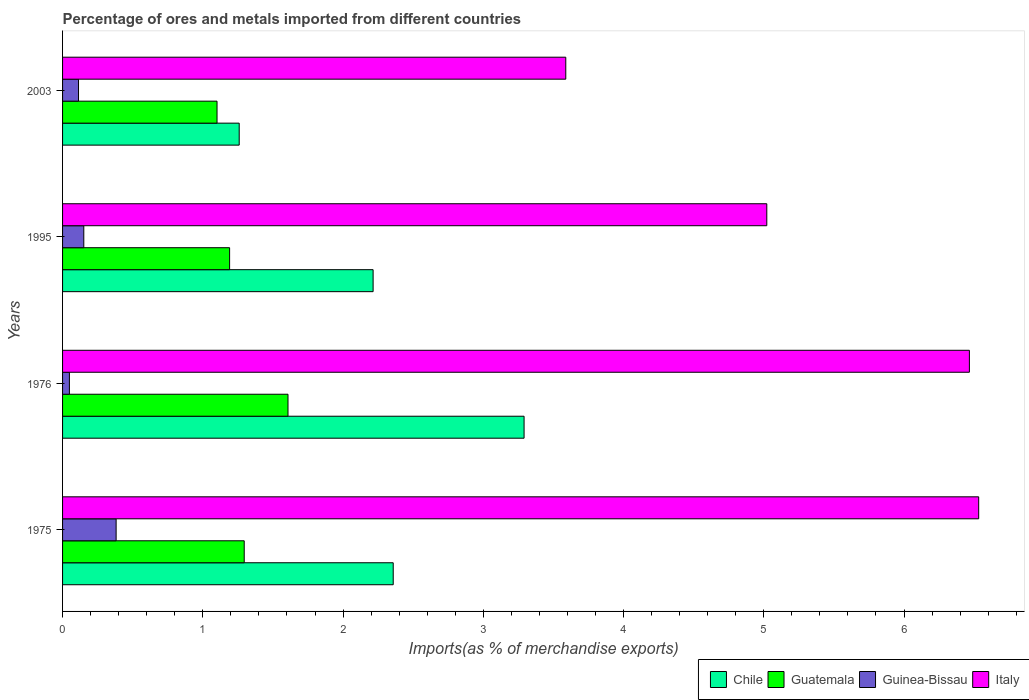How many different coloured bars are there?
Provide a succinct answer. 4. How many groups of bars are there?
Your answer should be compact. 4. Are the number of bars per tick equal to the number of legend labels?
Offer a terse response. Yes. Are the number of bars on each tick of the Y-axis equal?
Provide a succinct answer. Yes. How many bars are there on the 2nd tick from the bottom?
Ensure brevity in your answer.  4. What is the percentage of imports to different countries in Italy in 1976?
Give a very brief answer. 6.47. Across all years, what is the maximum percentage of imports to different countries in Chile?
Offer a very short reply. 3.29. Across all years, what is the minimum percentage of imports to different countries in Italy?
Your response must be concise. 3.59. In which year was the percentage of imports to different countries in Italy maximum?
Your answer should be compact. 1975. What is the total percentage of imports to different countries in Guinea-Bissau in the graph?
Your response must be concise. 0.7. What is the difference between the percentage of imports to different countries in Guatemala in 1976 and that in 2003?
Offer a terse response. 0.51. What is the difference between the percentage of imports to different countries in Italy in 1995 and the percentage of imports to different countries in Guinea-Bissau in 2003?
Ensure brevity in your answer.  4.91. What is the average percentage of imports to different countries in Italy per year?
Your answer should be compact. 5.4. In the year 2003, what is the difference between the percentage of imports to different countries in Guinea-Bissau and percentage of imports to different countries in Chile?
Offer a terse response. -1.15. In how many years, is the percentage of imports to different countries in Guatemala greater than 6.4 %?
Ensure brevity in your answer.  0. What is the ratio of the percentage of imports to different countries in Chile in 1975 to that in 1995?
Your answer should be very brief. 1.06. Is the difference between the percentage of imports to different countries in Guinea-Bissau in 1975 and 1995 greater than the difference between the percentage of imports to different countries in Chile in 1975 and 1995?
Ensure brevity in your answer.  Yes. What is the difference between the highest and the second highest percentage of imports to different countries in Guatemala?
Offer a terse response. 0.31. What is the difference between the highest and the lowest percentage of imports to different countries in Guatemala?
Make the answer very short. 0.51. Is it the case that in every year, the sum of the percentage of imports to different countries in Guatemala and percentage of imports to different countries in Guinea-Bissau is greater than the sum of percentage of imports to different countries in Italy and percentage of imports to different countries in Chile?
Provide a short and direct response. No. Is it the case that in every year, the sum of the percentage of imports to different countries in Guinea-Bissau and percentage of imports to different countries in Chile is greater than the percentage of imports to different countries in Italy?
Provide a succinct answer. No. How many bars are there?
Your response must be concise. 16. Does the graph contain any zero values?
Offer a terse response. No. Where does the legend appear in the graph?
Your response must be concise. Bottom right. How are the legend labels stacked?
Give a very brief answer. Horizontal. What is the title of the graph?
Your answer should be compact. Percentage of ores and metals imported from different countries. Does "Iceland" appear as one of the legend labels in the graph?
Make the answer very short. No. What is the label or title of the X-axis?
Give a very brief answer. Imports(as % of merchandise exports). What is the label or title of the Y-axis?
Provide a succinct answer. Years. What is the Imports(as % of merchandise exports) of Chile in 1975?
Your answer should be very brief. 2.36. What is the Imports(as % of merchandise exports) in Guatemala in 1975?
Keep it short and to the point. 1.3. What is the Imports(as % of merchandise exports) of Guinea-Bissau in 1975?
Your answer should be very brief. 0.38. What is the Imports(as % of merchandise exports) in Italy in 1975?
Give a very brief answer. 6.53. What is the Imports(as % of merchandise exports) of Chile in 1976?
Your response must be concise. 3.29. What is the Imports(as % of merchandise exports) in Guatemala in 1976?
Your response must be concise. 1.61. What is the Imports(as % of merchandise exports) in Guinea-Bissau in 1976?
Give a very brief answer. 0.05. What is the Imports(as % of merchandise exports) of Italy in 1976?
Ensure brevity in your answer.  6.47. What is the Imports(as % of merchandise exports) in Chile in 1995?
Offer a terse response. 2.21. What is the Imports(as % of merchandise exports) of Guatemala in 1995?
Your response must be concise. 1.19. What is the Imports(as % of merchandise exports) of Guinea-Bissau in 1995?
Give a very brief answer. 0.15. What is the Imports(as % of merchandise exports) in Italy in 1995?
Offer a terse response. 5.02. What is the Imports(as % of merchandise exports) of Chile in 2003?
Ensure brevity in your answer.  1.26. What is the Imports(as % of merchandise exports) of Guatemala in 2003?
Your answer should be compact. 1.1. What is the Imports(as % of merchandise exports) of Guinea-Bissau in 2003?
Provide a short and direct response. 0.11. What is the Imports(as % of merchandise exports) in Italy in 2003?
Provide a succinct answer. 3.59. Across all years, what is the maximum Imports(as % of merchandise exports) of Chile?
Make the answer very short. 3.29. Across all years, what is the maximum Imports(as % of merchandise exports) of Guatemala?
Your answer should be compact. 1.61. Across all years, what is the maximum Imports(as % of merchandise exports) of Guinea-Bissau?
Keep it short and to the point. 0.38. Across all years, what is the maximum Imports(as % of merchandise exports) in Italy?
Your answer should be compact. 6.53. Across all years, what is the minimum Imports(as % of merchandise exports) in Chile?
Ensure brevity in your answer.  1.26. Across all years, what is the minimum Imports(as % of merchandise exports) in Guatemala?
Your response must be concise. 1.1. Across all years, what is the minimum Imports(as % of merchandise exports) of Guinea-Bissau?
Your response must be concise. 0.05. Across all years, what is the minimum Imports(as % of merchandise exports) in Italy?
Make the answer very short. 3.59. What is the total Imports(as % of merchandise exports) of Chile in the graph?
Offer a terse response. 9.12. What is the total Imports(as % of merchandise exports) of Guatemala in the graph?
Your answer should be compact. 5.2. What is the total Imports(as % of merchandise exports) of Guinea-Bissau in the graph?
Your answer should be compact. 0.7. What is the total Imports(as % of merchandise exports) of Italy in the graph?
Provide a short and direct response. 21.61. What is the difference between the Imports(as % of merchandise exports) in Chile in 1975 and that in 1976?
Keep it short and to the point. -0.93. What is the difference between the Imports(as % of merchandise exports) of Guatemala in 1975 and that in 1976?
Your response must be concise. -0.31. What is the difference between the Imports(as % of merchandise exports) of Guinea-Bissau in 1975 and that in 1976?
Provide a succinct answer. 0.33. What is the difference between the Imports(as % of merchandise exports) in Italy in 1975 and that in 1976?
Offer a very short reply. 0.07. What is the difference between the Imports(as % of merchandise exports) of Chile in 1975 and that in 1995?
Provide a succinct answer. 0.14. What is the difference between the Imports(as % of merchandise exports) in Guatemala in 1975 and that in 1995?
Make the answer very short. 0.1. What is the difference between the Imports(as % of merchandise exports) of Guinea-Bissau in 1975 and that in 1995?
Offer a very short reply. 0.23. What is the difference between the Imports(as % of merchandise exports) in Italy in 1975 and that in 1995?
Offer a terse response. 1.51. What is the difference between the Imports(as % of merchandise exports) in Chile in 1975 and that in 2003?
Offer a very short reply. 1.1. What is the difference between the Imports(as % of merchandise exports) in Guatemala in 1975 and that in 2003?
Your answer should be compact. 0.19. What is the difference between the Imports(as % of merchandise exports) in Guinea-Bissau in 1975 and that in 2003?
Your answer should be compact. 0.27. What is the difference between the Imports(as % of merchandise exports) in Italy in 1975 and that in 2003?
Provide a succinct answer. 2.94. What is the difference between the Imports(as % of merchandise exports) of Chile in 1976 and that in 1995?
Offer a terse response. 1.08. What is the difference between the Imports(as % of merchandise exports) of Guatemala in 1976 and that in 1995?
Your response must be concise. 0.42. What is the difference between the Imports(as % of merchandise exports) in Guinea-Bissau in 1976 and that in 1995?
Your answer should be very brief. -0.1. What is the difference between the Imports(as % of merchandise exports) of Italy in 1976 and that in 1995?
Your response must be concise. 1.44. What is the difference between the Imports(as % of merchandise exports) of Chile in 1976 and that in 2003?
Your answer should be compact. 2.03. What is the difference between the Imports(as % of merchandise exports) in Guatemala in 1976 and that in 2003?
Your answer should be compact. 0.51. What is the difference between the Imports(as % of merchandise exports) in Guinea-Bissau in 1976 and that in 2003?
Offer a terse response. -0.07. What is the difference between the Imports(as % of merchandise exports) in Italy in 1976 and that in 2003?
Provide a succinct answer. 2.88. What is the difference between the Imports(as % of merchandise exports) in Chile in 1995 and that in 2003?
Ensure brevity in your answer.  0.95. What is the difference between the Imports(as % of merchandise exports) in Guatemala in 1995 and that in 2003?
Your answer should be very brief. 0.09. What is the difference between the Imports(as % of merchandise exports) in Guinea-Bissau in 1995 and that in 2003?
Keep it short and to the point. 0.04. What is the difference between the Imports(as % of merchandise exports) of Italy in 1995 and that in 2003?
Ensure brevity in your answer.  1.43. What is the difference between the Imports(as % of merchandise exports) in Chile in 1975 and the Imports(as % of merchandise exports) in Guatemala in 1976?
Offer a terse response. 0.75. What is the difference between the Imports(as % of merchandise exports) in Chile in 1975 and the Imports(as % of merchandise exports) in Guinea-Bissau in 1976?
Give a very brief answer. 2.31. What is the difference between the Imports(as % of merchandise exports) of Chile in 1975 and the Imports(as % of merchandise exports) of Italy in 1976?
Provide a short and direct response. -4.11. What is the difference between the Imports(as % of merchandise exports) of Guatemala in 1975 and the Imports(as % of merchandise exports) of Guinea-Bissau in 1976?
Offer a terse response. 1.25. What is the difference between the Imports(as % of merchandise exports) of Guatemala in 1975 and the Imports(as % of merchandise exports) of Italy in 1976?
Give a very brief answer. -5.17. What is the difference between the Imports(as % of merchandise exports) in Guinea-Bissau in 1975 and the Imports(as % of merchandise exports) in Italy in 1976?
Offer a terse response. -6.08. What is the difference between the Imports(as % of merchandise exports) in Chile in 1975 and the Imports(as % of merchandise exports) in Guatemala in 1995?
Your answer should be compact. 1.17. What is the difference between the Imports(as % of merchandise exports) of Chile in 1975 and the Imports(as % of merchandise exports) of Guinea-Bissau in 1995?
Provide a succinct answer. 2.21. What is the difference between the Imports(as % of merchandise exports) of Chile in 1975 and the Imports(as % of merchandise exports) of Italy in 1995?
Offer a very short reply. -2.66. What is the difference between the Imports(as % of merchandise exports) in Guatemala in 1975 and the Imports(as % of merchandise exports) in Guinea-Bissau in 1995?
Offer a very short reply. 1.14. What is the difference between the Imports(as % of merchandise exports) of Guatemala in 1975 and the Imports(as % of merchandise exports) of Italy in 1995?
Provide a short and direct response. -3.73. What is the difference between the Imports(as % of merchandise exports) in Guinea-Bissau in 1975 and the Imports(as % of merchandise exports) in Italy in 1995?
Provide a short and direct response. -4.64. What is the difference between the Imports(as % of merchandise exports) in Chile in 1975 and the Imports(as % of merchandise exports) in Guatemala in 2003?
Your answer should be compact. 1.26. What is the difference between the Imports(as % of merchandise exports) in Chile in 1975 and the Imports(as % of merchandise exports) in Guinea-Bissau in 2003?
Give a very brief answer. 2.24. What is the difference between the Imports(as % of merchandise exports) of Chile in 1975 and the Imports(as % of merchandise exports) of Italy in 2003?
Provide a succinct answer. -1.23. What is the difference between the Imports(as % of merchandise exports) in Guatemala in 1975 and the Imports(as % of merchandise exports) in Guinea-Bissau in 2003?
Your response must be concise. 1.18. What is the difference between the Imports(as % of merchandise exports) in Guatemala in 1975 and the Imports(as % of merchandise exports) in Italy in 2003?
Provide a short and direct response. -2.29. What is the difference between the Imports(as % of merchandise exports) of Guinea-Bissau in 1975 and the Imports(as % of merchandise exports) of Italy in 2003?
Your response must be concise. -3.21. What is the difference between the Imports(as % of merchandise exports) of Chile in 1976 and the Imports(as % of merchandise exports) of Guatemala in 1995?
Your answer should be compact. 2.1. What is the difference between the Imports(as % of merchandise exports) of Chile in 1976 and the Imports(as % of merchandise exports) of Guinea-Bissau in 1995?
Your answer should be compact. 3.14. What is the difference between the Imports(as % of merchandise exports) in Chile in 1976 and the Imports(as % of merchandise exports) in Italy in 1995?
Provide a short and direct response. -1.73. What is the difference between the Imports(as % of merchandise exports) of Guatemala in 1976 and the Imports(as % of merchandise exports) of Guinea-Bissau in 1995?
Make the answer very short. 1.46. What is the difference between the Imports(as % of merchandise exports) of Guatemala in 1976 and the Imports(as % of merchandise exports) of Italy in 1995?
Your response must be concise. -3.41. What is the difference between the Imports(as % of merchandise exports) in Guinea-Bissau in 1976 and the Imports(as % of merchandise exports) in Italy in 1995?
Provide a short and direct response. -4.97. What is the difference between the Imports(as % of merchandise exports) of Chile in 1976 and the Imports(as % of merchandise exports) of Guatemala in 2003?
Offer a terse response. 2.19. What is the difference between the Imports(as % of merchandise exports) of Chile in 1976 and the Imports(as % of merchandise exports) of Guinea-Bissau in 2003?
Provide a short and direct response. 3.18. What is the difference between the Imports(as % of merchandise exports) of Chile in 1976 and the Imports(as % of merchandise exports) of Italy in 2003?
Your answer should be compact. -0.3. What is the difference between the Imports(as % of merchandise exports) in Guatemala in 1976 and the Imports(as % of merchandise exports) in Guinea-Bissau in 2003?
Your answer should be compact. 1.49. What is the difference between the Imports(as % of merchandise exports) in Guatemala in 1976 and the Imports(as % of merchandise exports) in Italy in 2003?
Provide a short and direct response. -1.98. What is the difference between the Imports(as % of merchandise exports) in Guinea-Bissau in 1976 and the Imports(as % of merchandise exports) in Italy in 2003?
Provide a short and direct response. -3.54. What is the difference between the Imports(as % of merchandise exports) of Chile in 1995 and the Imports(as % of merchandise exports) of Guatemala in 2003?
Ensure brevity in your answer.  1.11. What is the difference between the Imports(as % of merchandise exports) of Chile in 1995 and the Imports(as % of merchandise exports) of Guinea-Bissau in 2003?
Your response must be concise. 2.1. What is the difference between the Imports(as % of merchandise exports) of Chile in 1995 and the Imports(as % of merchandise exports) of Italy in 2003?
Your answer should be very brief. -1.37. What is the difference between the Imports(as % of merchandise exports) in Guatemala in 1995 and the Imports(as % of merchandise exports) in Guinea-Bissau in 2003?
Offer a very short reply. 1.08. What is the difference between the Imports(as % of merchandise exports) in Guatemala in 1995 and the Imports(as % of merchandise exports) in Italy in 2003?
Your response must be concise. -2.4. What is the difference between the Imports(as % of merchandise exports) in Guinea-Bissau in 1995 and the Imports(as % of merchandise exports) in Italy in 2003?
Keep it short and to the point. -3.44. What is the average Imports(as % of merchandise exports) of Chile per year?
Make the answer very short. 2.28. What is the average Imports(as % of merchandise exports) of Guatemala per year?
Your response must be concise. 1.3. What is the average Imports(as % of merchandise exports) in Guinea-Bissau per year?
Give a very brief answer. 0.17. What is the average Imports(as % of merchandise exports) of Italy per year?
Your response must be concise. 5.4. In the year 1975, what is the difference between the Imports(as % of merchandise exports) in Chile and Imports(as % of merchandise exports) in Guatemala?
Offer a very short reply. 1.06. In the year 1975, what is the difference between the Imports(as % of merchandise exports) of Chile and Imports(as % of merchandise exports) of Guinea-Bissau?
Give a very brief answer. 1.98. In the year 1975, what is the difference between the Imports(as % of merchandise exports) in Chile and Imports(as % of merchandise exports) in Italy?
Provide a succinct answer. -4.17. In the year 1975, what is the difference between the Imports(as % of merchandise exports) in Guatemala and Imports(as % of merchandise exports) in Guinea-Bissau?
Ensure brevity in your answer.  0.91. In the year 1975, what is the difference between the Imports(as % of merchandise exports) in Guatemala and Imports(as % of merchandise exports) in Italy?
Give a very brief answer. -5.24. In the year 1975, what is the difference between the Imports(as % of merchandise exports) in Guinea-Bissau and Imports(as % of merchandise exports) in Italy?
Your answer should be compact. -6.15. In the year 1976, what is the difference between the Imports(as % of merchandise exports) of Chile and Imports(as % of merchandise exports) of Guatemala?
Provide a short and direct response. 1.68. In the year 1976, what is the difference between the Imports(as % of merchandise exports) of Chile and Imports(as % of merchandise exports) of Guinea-Bissau?
Give a very brief answer. 3.24. In the year 1976, what is the difference between the Imports(as % of merchandise exports) of Chile and Imports(as % of merchandise exports) of Italy?
Offer a very short reply. -3.18. In the year 1976, what is the difference between the Imports(as % of merchandise exports) of Guatemala and Imports(as % of merchandise exports) of Guinea-Bissau?
Offer a terse response. 1.56. In the year 1976, what is the difference between the Imports(as % of merchandise exports) of Guatemala and Imports(as % of merchandise exports) of Italy?
Offer a terse response. -4.86. In the year 1976, what is the difference between the Imports(as % of merchandise exports) of Guinea-Bissau and Imports(as % of merchandise exports) of Italy?
Your answer should be very brief. -6.42. In the year 1995, what is the difference between the Imports(as % of merchandise exports) in Chile and Imports(as % of merchandise exports) in Guatemala?
Make the answer very short. 1.02. In the year 1995, what is the difference between the Imports(as % of merchandise exports) of Chile and Imports(as % of merchandise exports) of Guinea-Bissau?
Provide a succinct answer. 2.06. In the year 1995, what is the difference between the Imports(as % of merchandise exports) of Chile and Imports(as % of merchandise exports) of Italy?
Offer a terse response. -2.81. In the year 1995, what is the difference between the Imports(as % of merchandise exports) of Guatemala and Imports(as % of merchandise exports) of Guinea-Bissau?
Your answer should be compact. 1.04. In the year 1995, what is the difference between the Imports(as % of merchandise exports) of Guatemala and Imports(as % of merchandise exports) of Italy?
Ensure brevity in your answer.  -3.83. In the year 1995, what is the difference between the Imports(as % of merchandise exports) of Guinea-Bissau and Imports(as % of merchandise exports) of Italy?
Offer a terse response. -4.87. In the year 2003, what is the difference between the Imports(as % of merchandise exports) in Chile and Imports(as % of merchandise exports) in Guatemala?
Your answer should be very brief. 0.16. In the year 2003, what is the difference between the Imports(as % of merchandise exports) in Chile and Imports(as % of merchandise exports) in Guinea-Bissau?
Your answer should be very brief. 1.15. In the year 2003, what is the difference between the Imports(as % of merchandise exports) in Chile and Imports(as % of merchandise exports) in Italy?
Your answer should be very brief. -2.33. In the year 2003, what is the difference between the Imports(as % of merchandise exports) in Guatemala and Imports(as % of merchandise exports) in Italy?
Your answer should be compact. -2.49. In the year 2003, what is the difference between the Imports(as % of merchandise exports) in Guinea-Bissau and Imports(as % of merchandise exports) in Italy?
Keep it short and to the point. -3.47. What is the ratio of the Imports(as % of merchandise exports) of Chile in 1975 to that in 1976?
Your answer should be very brief. 0.72. What is the ratio of the Imports(as % of merchandise exports) of Guatemala in 1975 to that in 1976?
Your response must be concise. 0.81. What is the ratio of the Imports(as % of merchandise exports) in Guinea-Bissau in 1975 to that in 1976?
Offer a terse response. 7.84. What is the ratio of the Imports(as % of merchandise exports) in Italy in 1975 to that in 1976?
Give a very brief answer. 1.01. What is the ratio of the Imports(as % of merchandise exports) of Chile in 1975 to that in 1995?
Keep it short and to the point. 1.06. What is the ratio of the Imports(as % of merchandise exports) in Guatemala in 1975 to that in 1995?
Give a very brief answer. 1.09. What is the ratio of the Imports(as % of merchandise exports) in Guinea-Bissau in 1975 to that in 1995?
Keep it short and to the point. 2.52. What is the ratio of the Imports(as % of merchandise exports) in Italy in 1975 to that in 1995?
Provide a succinct answer. 1.3. What is the ratio of the Imports(as % of merchandise exports) of Chile in 1975 to that in 2003?
Offer a very short reply. 1.87. What is the ratio of the Imports(as % of merchandise exports) of Guatemala in 1975 to that in 2003?
Provide a short and direct response. 1.18. What is the ratio of the Imports(as % of merchandise exports) in Guinea-Bissau in 1975 to that in 2003?
Your answer should be compact. 3.36. What is the ratio of the Imports(as % of merchandise exports) in Italy in 1975 to that in 2003?
Make the answer very short. 1.82. What is the ratio of the Imports(as % of merchandise exports) in Chile in 1976 to that in 1995?
Offer a very short reply. 1.49. What is the ratio of the Imports(as % of merchandise exports) in Guatemala in 1976 to that in 1995?
Your response must be concise. 1.35. What is the ratio of the Imports(as % of merchandise exports) of Guinea-Bissau in 1976 to that in 1995?
Keep it short and to the point. 0.32. What is the ratio of the Imports(as % of merchandise exports) in Italy in 1976 to that in 1995?
Provide a short and direct response. 1.29. What is the ratio of the Imports(as % of merchandise exports) in Chile in 1976 to that in 2003?
Your response must be concise. 2.61. What is the ratio of the Imports(as % of merchandise exports) in Guatemala in 1976 to that in 2003?
Provide a short and direct response. 1.46. What is the ratio of the Imports(as % of merchandise exports) in Guinea-Bissau in 1976 to that in 2003?
Offer a terse response. 0.43. What is the ratio of the Imports(as % of merchandise exports) in Italy in 1976 to that in 2003?
Give a very brief answer. 1.8. What is the ratio of the Imports(as % of merchandise exports) of Chile in 1995 to that in 2003?
Provide a succinct answer. 1.76. What is the ratio of the Imports(as % of merchandise exports) of Guatemala in 1995 to that in 2003?
Provide a short and direct response. 1.08. What is the ratio of the Imports(as % of merchandise exports) of Guinea-Bissau in 1995 to that in 2003?
Your response must be concise. 1.33. What is the ratio of the Imports(as % of merchandise exports) of Italy in 1995 to that in 2003?
Offer a very short reply. 1.4. What is the difference between the highest and the second highest Imports(as % of merchandise exports) in Chile?
Your response must be concise. 0.93. What is the difference between the highest and the second highest Imports(as % of merchandise exports) of Guatemala?
Your answer should be compact. 0.31. What is the difference between the highest and the second highest Imports(as % of merchandise exports) in Guinea-Bissau?
Your response must be concise. 0.23. What is the difference between the highest and the second highest Imports(as % of merchandise exports) of Italy?
Provide a succinct answer. 0.07. What is the difference between the highest and the lowest Imports(as % of merchandise exports) of Chile?
Make the answer very short. 2.03. What is the difference between the highest and the lowest Imports(as % of merchandise exports) of Guatemala?
Your response must be concise. 0.51. What is the difference between the highest and the lowest Imports(as % of merchandise exports) of Guinea-Bissau?
Your response must be concise. 0.33. What is the difference between the highest and the lowest Imports(as % of merchandise exports) in Italy?
Your answer should be compact. 2.94. 